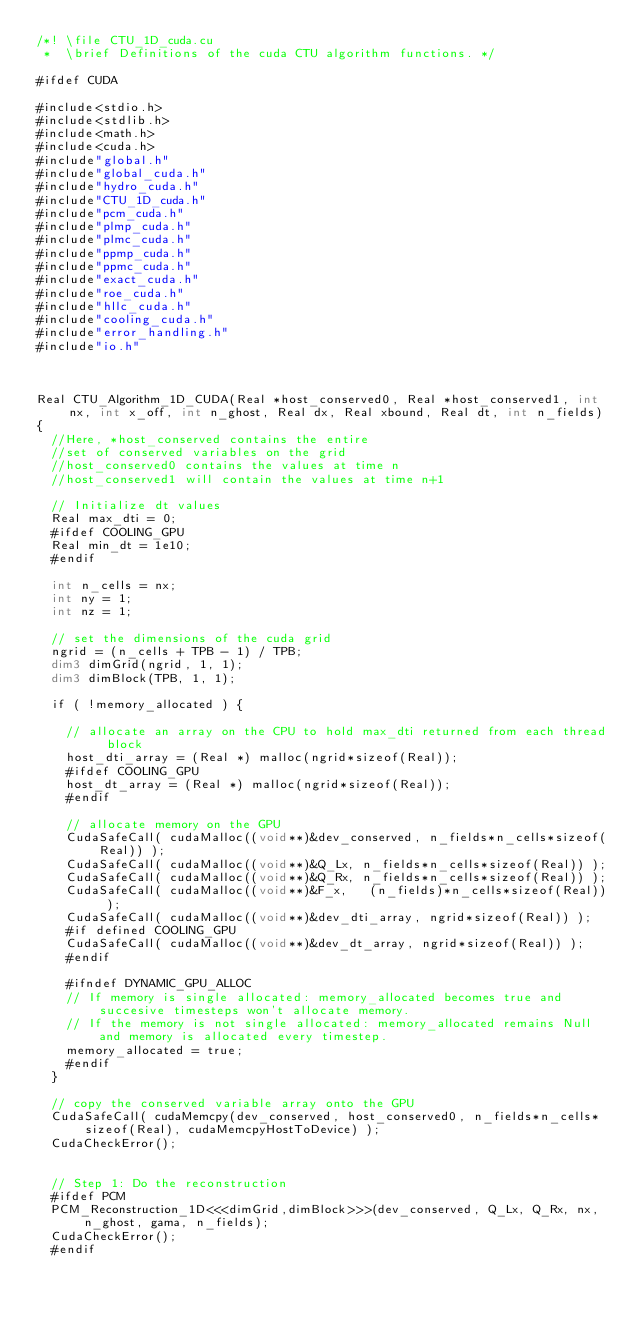<code> <loc_0><loc_0><loc_500><loc_500><_Cuda_>/*! \file CTU_1D_cuda.cu
 *  \brief Definitions of the cuda CTU algorithm functions. */

#ifdef CUDA

#include<stdio.h>
#include<stdlib.h>
#include<math.h>
#include<cuda.h>
#include"global.h"
#include"global_cuda.h"
#include"hydro_cuda.h"
#include"CTU_1D_cuda.h"
#include"pcm_cuda.h"
#include"plmp_cuda.h"
#include"plmc_cuda.h"
#include"ppmp_cuda.h"
#include"ppmc_cuda.h"
#include"exact_cuda.h"
#include"roe_cuda.h"
#include"hllc_cuda.h"
#include"cooling_cuda.h"
#include"error_handling.h"
#include"io.h"



Real CTU_Algorithm_1D_CUDA(Real *host_conserved0, Real *host_conserved1, int nx, int x_off, int n_ghost, Real dx, Real xbound, Real dt, int n_fields)
{
  //Here, *host_conserved contains the entire
  //set of conserved variables on the grid
  //host_conserved0 contains the values at time n
  //host_conserved1 will contain the values at time n+1

  // Initialize dt values
  Real max_dti = 0;
  #ifdef COOLING_GPU
  Real min_dt = 1e10;
  #endif  

  int n_cells = nx;
  int ny = 1;
  int nz = 1;

  // set the dimensions of the cuda grid
  ngrid = (n_cells + TPB - 1) / TPB;
  dim3 dimGrid(ngrid, 1, 1);
  dim3 dimBlock(TPB, 1, 1);

  if ( !memory_allocated ) {

    // allocate an array on the CPU to hold max_dti returned from each thread block
    host_dti_array = (Real *) malloc(ngrid*sizeof(Real));
    #ifdef COOLING_GPU
    host_dt_array = (Real *) malloc(ngrid*sizeof(Real));
    #endif

    // allocate memory on the GPU
    CudaSafeCall( cudaMalloc((void**)&dev_conserved, n_fields*n_cells*sizeof(Real)) );
    CudaSafeCall( cudaMalloc((void**)&Q_Lx, n_fields*n_cells*sizeof(Real)) );
    CudaSafeCall( cudaMalloc((void**)&Q_Rx, n_fields*n_cells*sizeof(Real)) );
    CudaSafeCall( cudaMalloc((void**)&F_x,   (n_fields)*n_cells*sizeof(Real)) );
    CudaSafeCall( cudaMalloc((void**)&dev_dti_array, ngrid*sizeof(Real)) );
    #if defined COOLING_GPU
    CudaSafeCall( cudaMalloc((void**)&dev_dt_array, ngrid*sizeof(Real)) );
    #endif  

    #ifndef DYNAMIC_GPU_ALLOC 
    // If memory is single allocated: memory_allocated becomes true and succesive timesteps won't allocate memory.
    // If the memory is not single allocated: memory_allocated remains Null and memory is allocated every timestep.
    memory_allocated = true;
    #endif 
  }

  // copy the conserved variable array onto the GPU
  CudaSafeCall( cudaMemcpy(dev_conserved, host_conserved0, n_fields*n_cells*sizeof(Real), cudaMemcpyHostToDevice) );
  CudaCheckError();


  // Step 1: Do the reconstruction
  #ifdef PCM
  PCM_Reconstruction_1D<<<dimGrid,dimBlock>>>(dev_conserved, Q_Lx, Q_Rx, nx, n_ghost, gama, n_fields);
  CudaCheckError();
  #endif</code> 